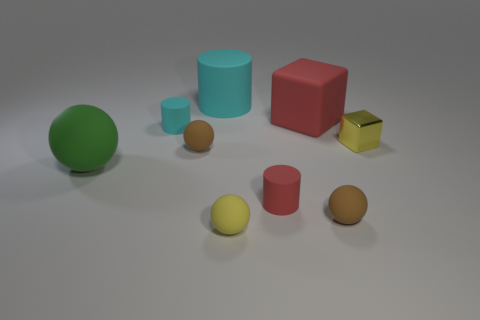Add 1 tiny red objects. How many objects exist? 10 Subtract all spheres. How many objects are left? 5 Add 1 large blocks. How many large blocks exist? 2 Subtract 0 purple spheres. How many objects are left? 9 Subtract all cylinders. Subtract all small cyan metallic spheres. How many objects are left? 6 Add 8 tiny red matte objects. How many tiny red matte objects are left? 9 